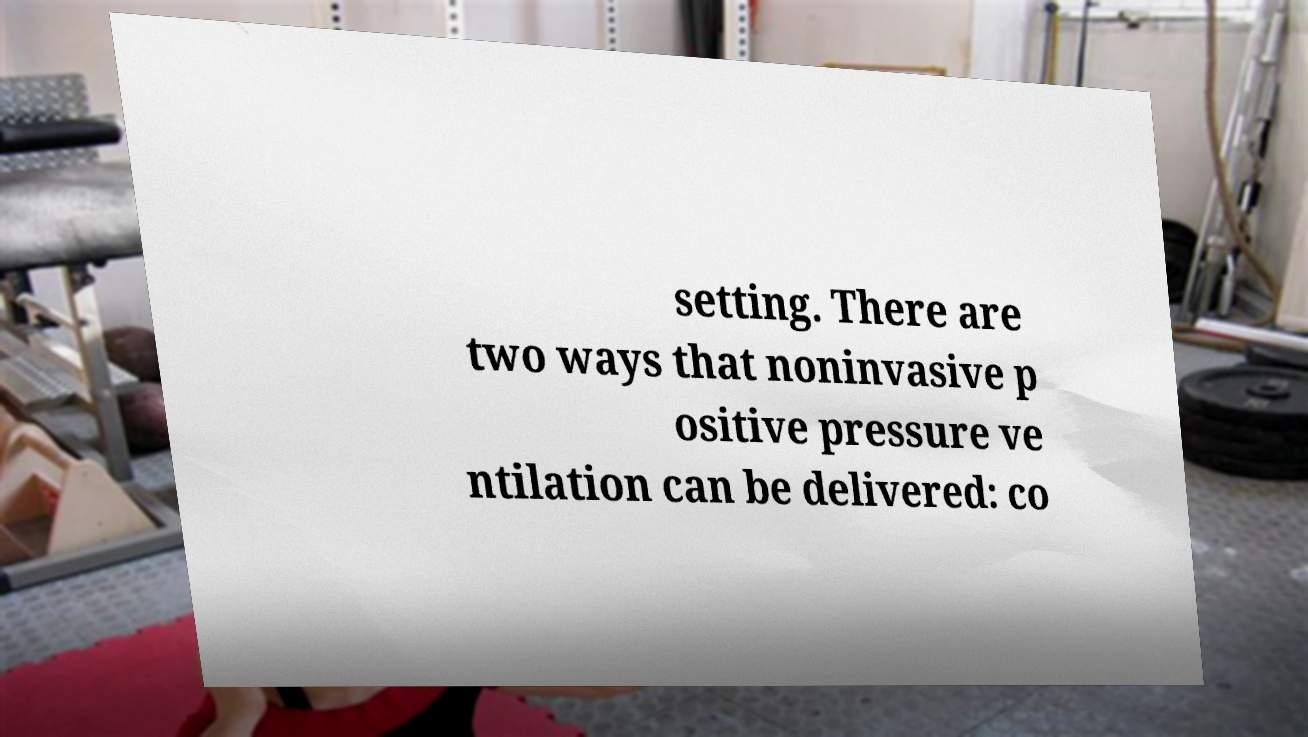I need the written content from this picture converted into text. Can you do that? setting. There are two ways that noninvasive p ositive pressure ve ntilation can be delivered: co 